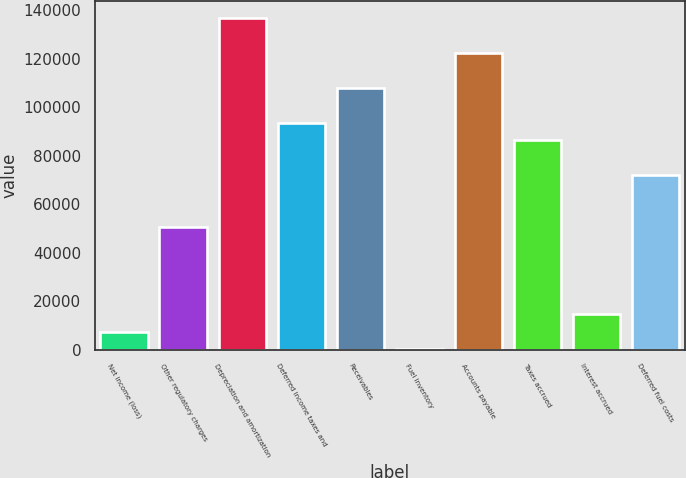Convert chart. <chart><loc_0><loc_0><loc_500><loc_500><bar_chart><fcel>Net income (loss)<fcel>Other regulatory charges<fcel>Depreciation and amortization<fcel>Deferred income taxes and<fcel>Receivables<fcel>Fuel inventory<fcel>Accounts payable<fcel>Taxes accrued<fcel>Interest accrued<fcel>Deferred fuel costs<nl><fcel>7397<fcel>50561<fcel>136889<fcel>93725<fcel>108113<fcel>203<fcel>122501<fcel>86531<fcel>14591<fcel>72143<nl></chart> 